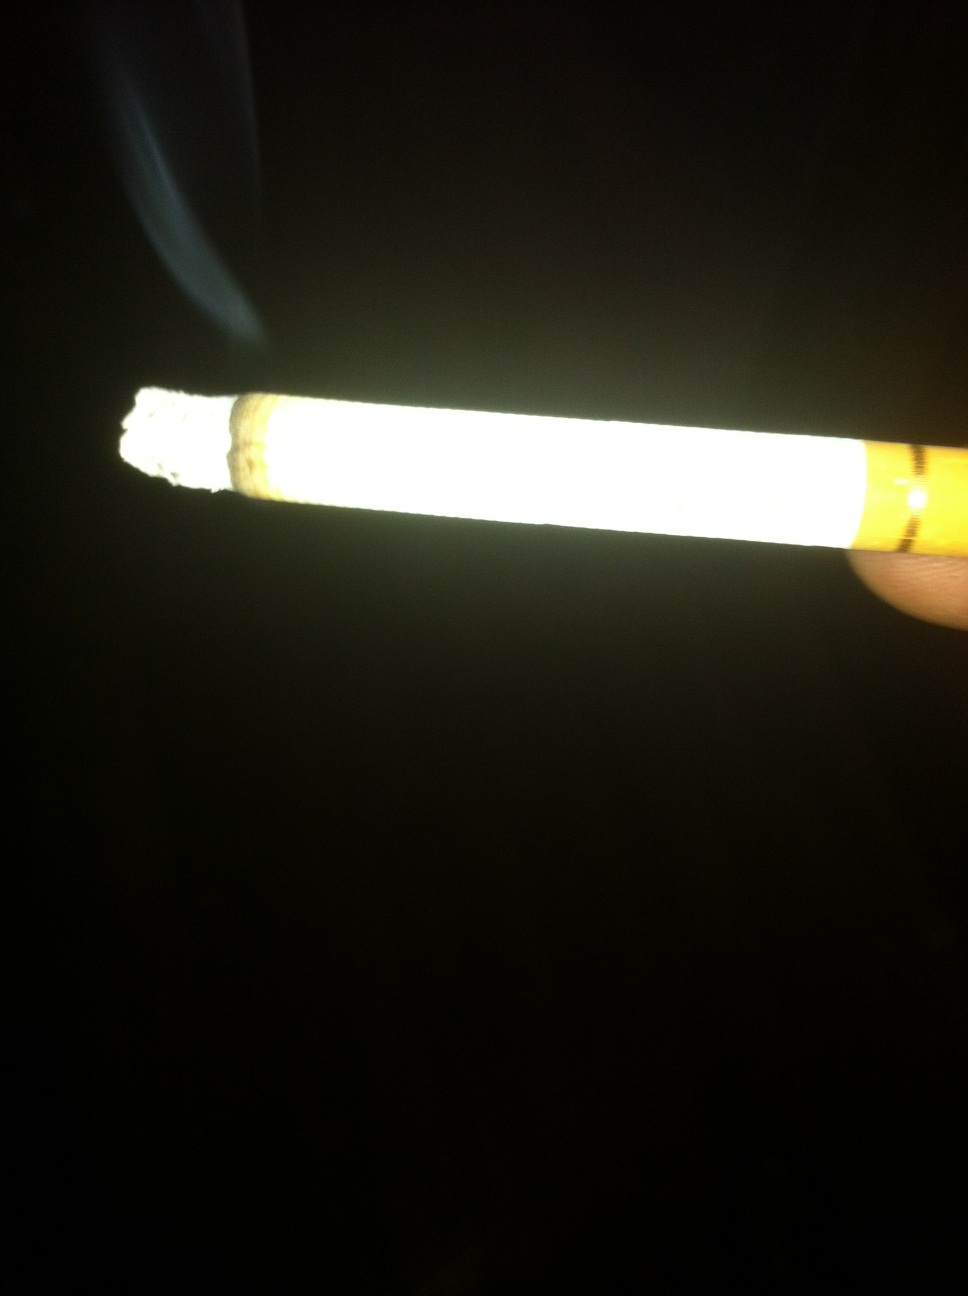What can you infer about the setting or the person holding the cigarette? Based on the darkness surrounding the lit cigarette, it's likely that the person is in a low-light environment, potentially outdoors at night. It's difficult to infer more about the person without additional visual information. 